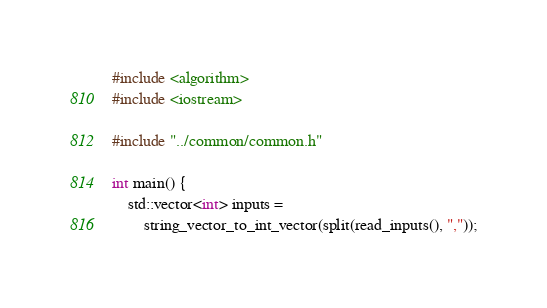Convert code to text. <code><loc_0><loc_0><loc_500><loc_500><_C++_>#include <algorithm>
#include <iostream>

#include "../common/common.h"

int main() {
    std::vector<int> inputs =
        string_vector_to_int_vector(split(read_inputs(), ","));</code> 